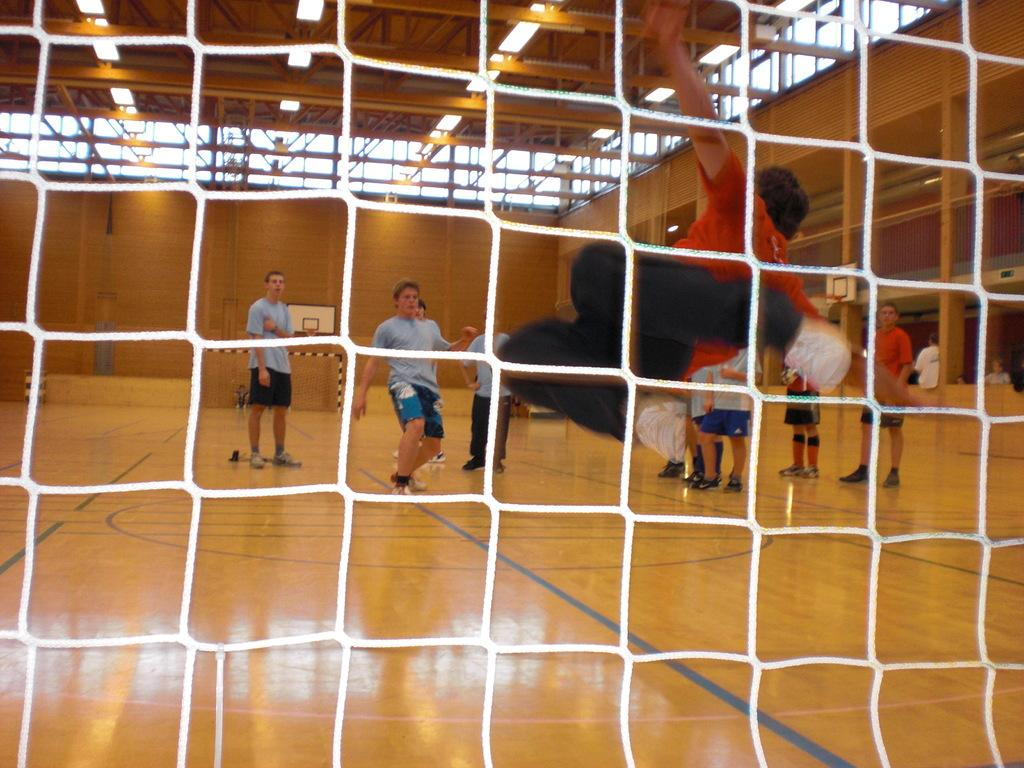What is the primary object in the image? There is a net in the image. What type of structure is visible in the image? There is a wall in the image. Can you describe the people present in the image? There are people present in the image. What type of peace symbol can be seen on the wall in the image? There is no peace symbol visible on the wall in the image. 